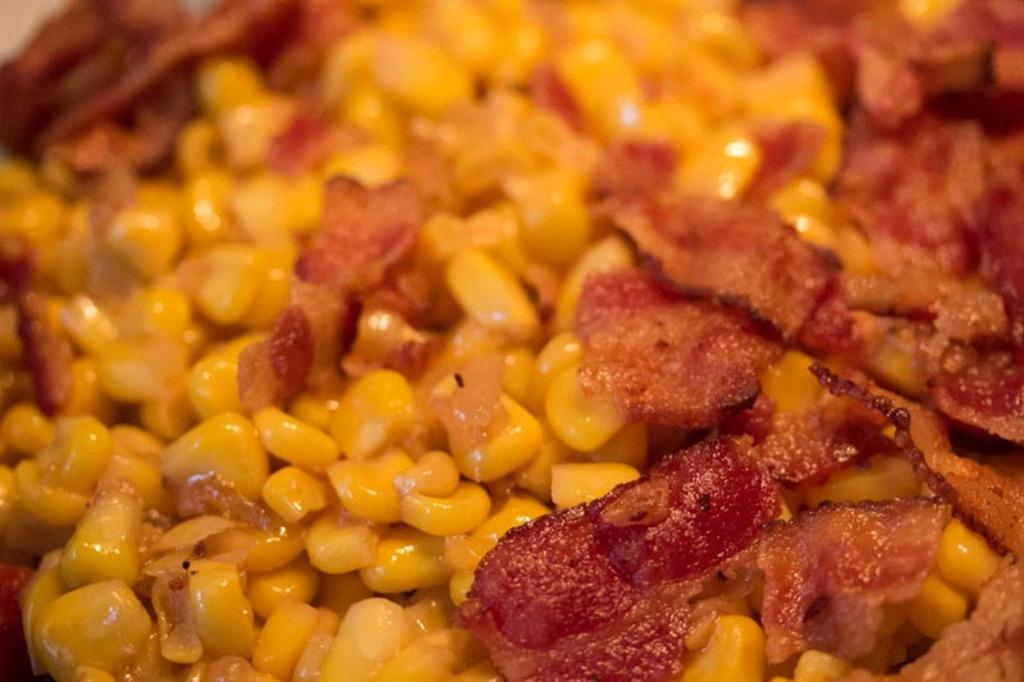What is present in the image? There is food in the image. Are there any toy bears on the island in the image? There is no mention of toys, bears, or an island in the image; it only contains food. 